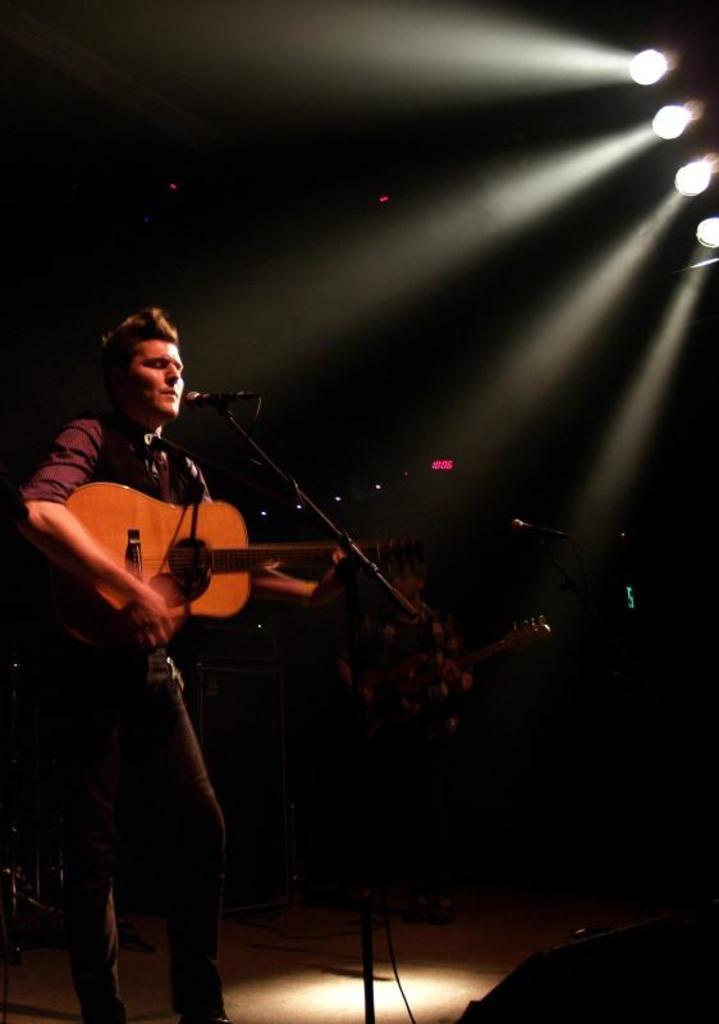How would you summarize this image in a sentence or two? In this picture there is a man who is holding a guitar and playing it in front of the mic and behind him there is an other person who is playing the guitar and some lights. 